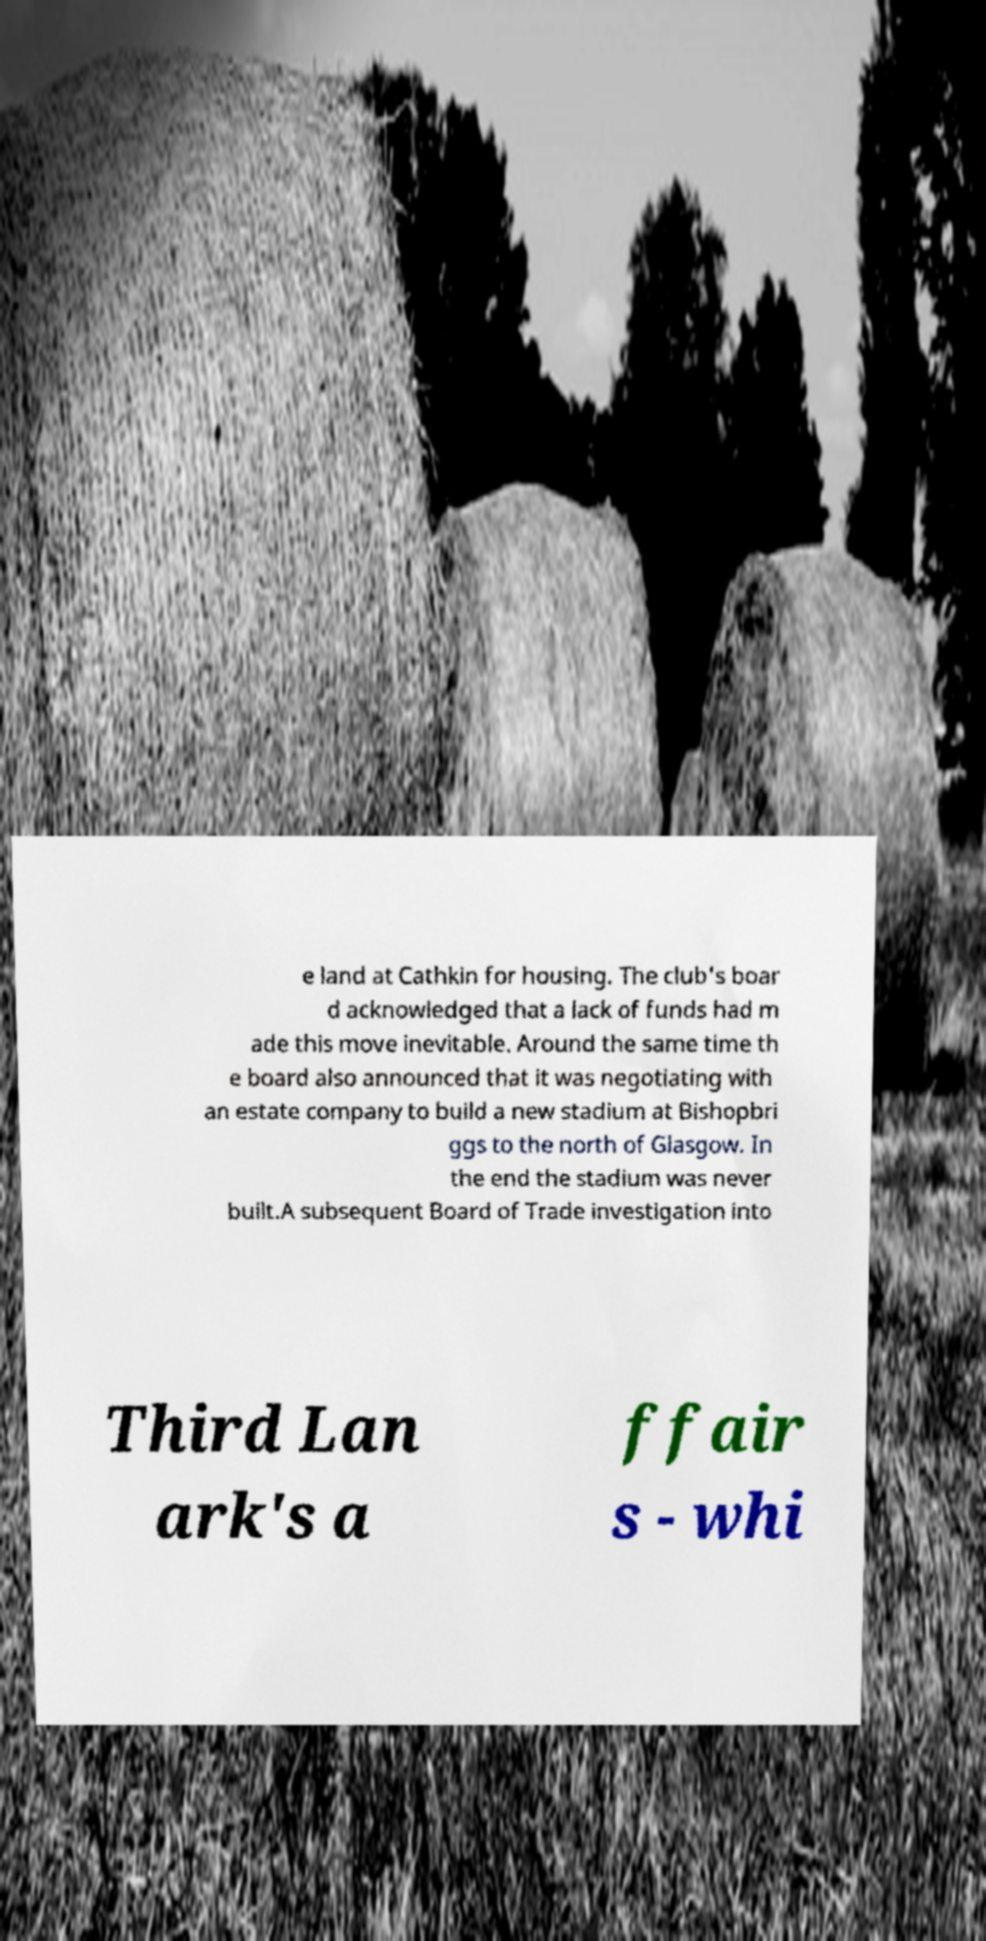Can you accurately transcribe the text from the provided image for me? e land at Cathkin for housing. The club's boar d acknowledged that a lack of funds had m ade this move inevitable. Around the same time th e board also announced that it was negotiating with an estate company to build a new stadium at Bishopbri ggs to the north of Glasgow. In the end the stadium was never built.A subsequent Board of Trade investigation into Third Lan ark's a ffair s - whi 